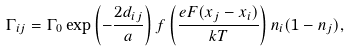<formula> <loc_0><loc_0><loc_500><loc_500>\Gamma _ { i j } = \Gamma _ { 0 } \exp \left ( - \frac { 2 d _ { i j } } { a } \right ) f \left ( \frac { e F ( x _ { j } - x _ { i } ) } { k T } \right ) n _ { i } ( 1 - n _ { j } ) ,</formula> 